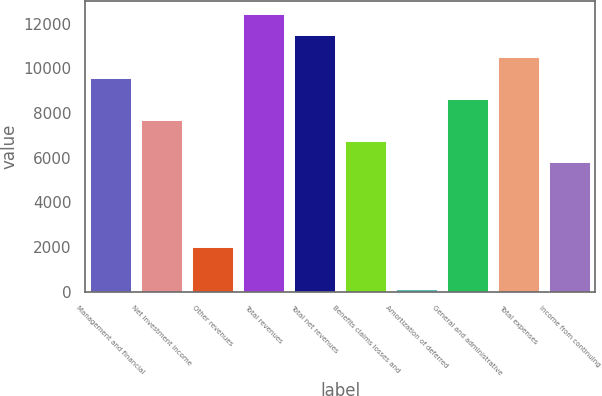Convert chart. <chart><loc_0><loc_0><loc_500><loc_500><bar_chart><fcel>Management and financial<fcel>Net investment income<fcel>Other revenues<fcel>Total revenues<fcel>Total net revenues<fcel>Benefits claims losses and<fcel>Amortization of deferred<fcel>General and administrative<fcel>Total expenses<fcel>Income from continuing<nl><fcel>9582<fcel>7691<fcel>2018<fcel>12418.5<fcel>11473<fcel>6745.5<fcel>127<fcel>8636.5<fcel>10527.5<fcel>5800<nl></chart> 